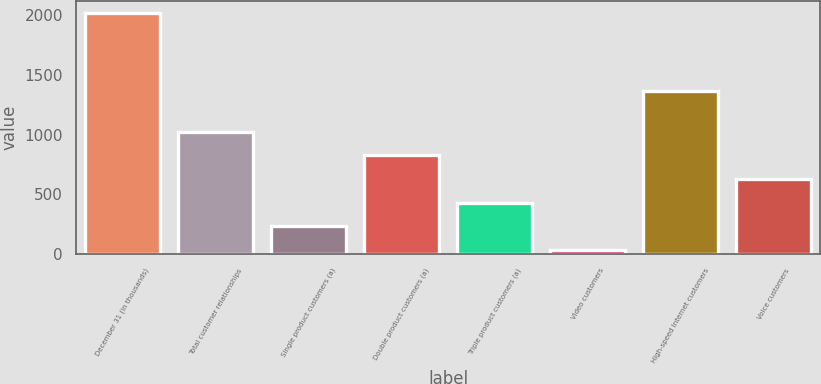<chart> <loc_0><loc_0><loc_500><loc_500><bar_chart><fcel>December 31 (in thousands)<fcel>Total customer relationships<fcel>Single product customers (a)<fcel>Double product customers (a)<fcel>Triple product customers (a)<fcel>Video customers<fcel>High-speed Internet customers<fcel>Voice customers<nl><fcel>2015<fcel>1025.5<fcel>233.9<fcel>827.6<fcel>431.8<fcel>36<fcel>1367<fcel>629.7<nl></chart> 